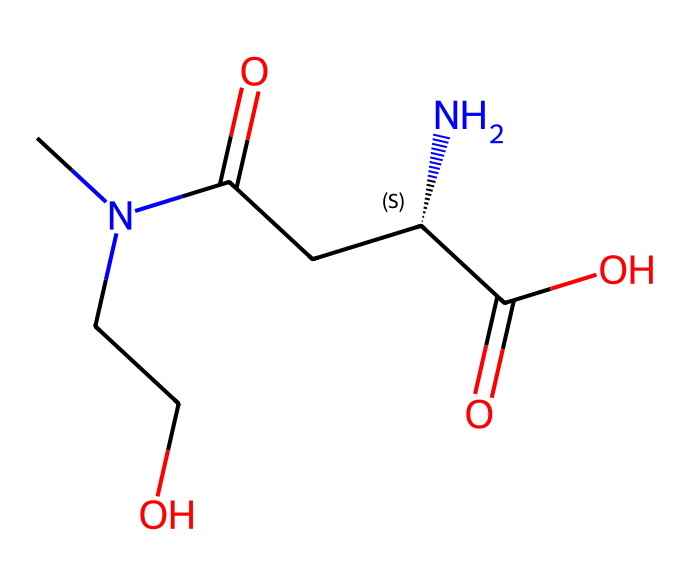What is the total number of carbon atoms in L-theanine? By examining the SMILES representation, we can identify each occurrence of 'C', which represents a carbon atom. Counting all the 'C' characters in the structure gives a total of 6 carbon atoms.
Answer: 6 How many nitrogen atoms are present in L-theanine? In the SMILES structure, nitrogen atoms are represented by the letter 'N'. There are two occurrences of 'N' in the chemical structure indicating that there are two nitrogen atoms.
Answer: 2 What functional groups can be identified in L-theanine? By analyzing the chemical structure, we can identify two main functional groups: an amide group (due to the presence of the -C(=O)N- fragment) and a carboxylic acid group (indicated by the -C(=O)O fragment).
Answer: amide and carboxylic acid Is L-theanine a chiral compound? The 'C@@H' notation in the SMILES indicates a chiral center, which means that L-theanine has a specific stereochemistry that leads to its chirality.
Answer: yes What is the degree of saturation in L-theanine? The degree of saturation can be determined from the structure; it indicates how many hydrogen atoms can be connected to the carbon skeleton without creating double or triple bonds. By analyzing the structure, this compound has a degree of saturation of 0, confirming it is fully saturated.
Answer: 0 How many oxygen atoms are present in the chemical structure of L-theanine? The letter 'O' represents oxygen atoms, and by counting the occurrences in the SMILES structure, we find a total of 4 oxygen atoms in L-theanine.
Answer: 4 What is the type of the chiral center in L-theanine? The chiral center is represented by the 'C@@H' in the SMILES notation, indicating that this specific carbon atom is tetrahedral and attached to four different substituents.
Answer: tetrahedral 